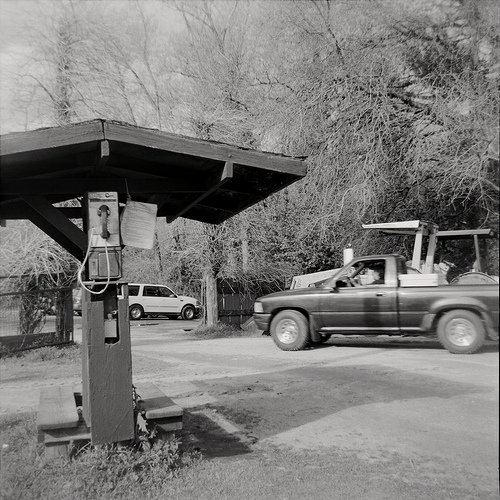Please provide the bounding box coordinate of the region this sentence describes: metal cable on pay phone. The bounding box for the metal cable on the pay phone is at coordinates [0.15, 0.46, 0.22, 0.59]. This area focuses on the cable extending from the pay phone attached to the wooden pole. 